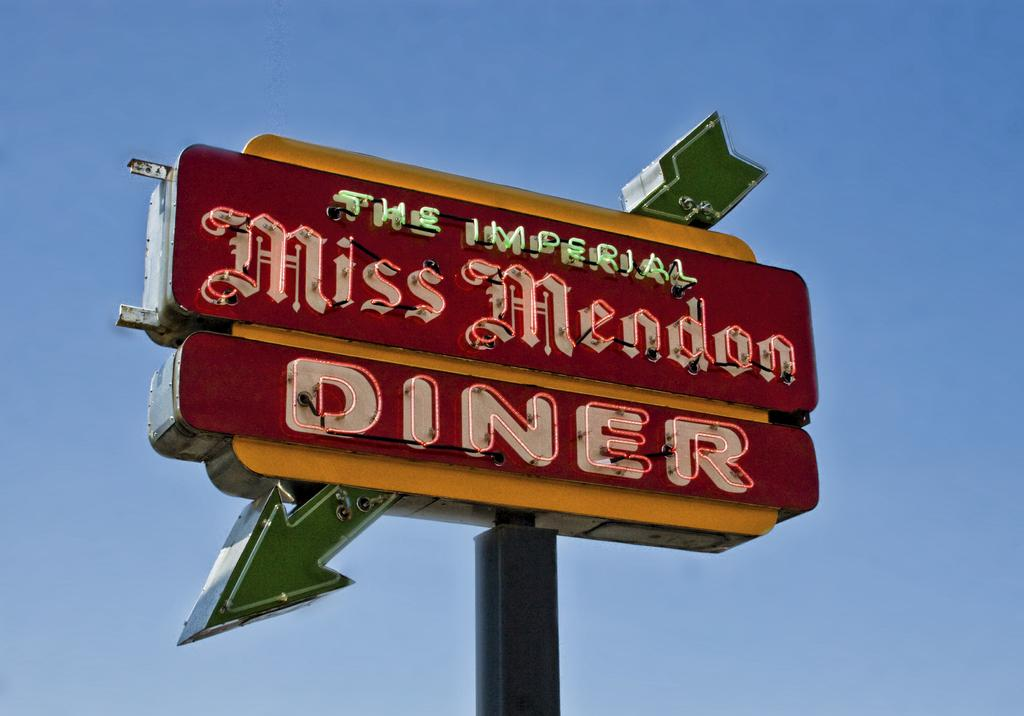<image>
Offer a succinct explanation of the picture presented. A red and yellow sign for The Imperial Miss Mendon Diner. 